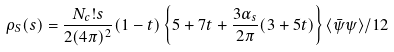<formula> <loc_0><loc_0><loc_500><loc_500>\rho _ { S } ( s ) = \frac { N _ { c } ! s } { 2 ( 4 \pi ) ^ { 2 } } ( 1 - t ) \left \{ 5 + 7 t + \frac { 3 \alpha _ { s } } { 2 \pi } ( 3 + 5 t ) \right \} \langle \bar { \psi } \psi \rangle / 1 2</formula> 